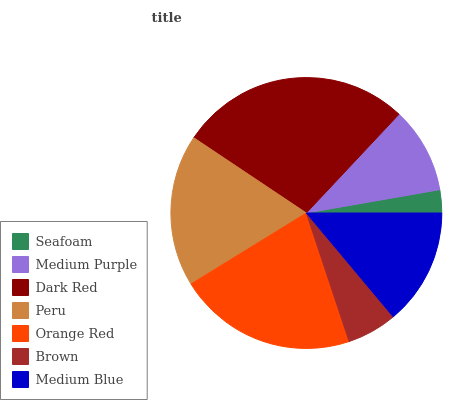Is Seafoam the minimum?
Answer yes or no. Yes. Is Dark Red the maximum?
Answer yes or no. Yes. Is Medium Purple the minimum?
Answer yes or no. No. Is Medium Purple the maximum?
Answer yes or no. No. Is Medium Purple greater than Seafoam?
Answer yes or no. Yes. Is Seafoam less than Medium Purple?
Answer yes or no. Yes. Is Seafoam greater than Medium Purple?
Answer yes or no. No. Is Medium Purple less than Seafoam?
Answer yes or no. No. Is Medium Blue the high median?
Answer yes or no. Yes. Is Medium Blue the low median?
Answer yes or no. Yes. Is Medium Purple the high median?
Answer yes or no. No. Is Brown the low median?
Answer yes or no. No. 